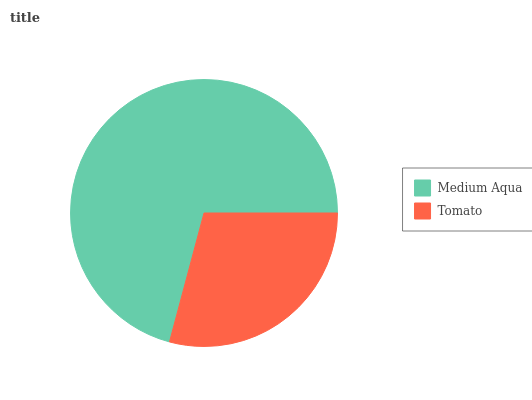Is Tomato the minimum?
Answer yes or no. Yes. Is Medium Aqua the maximum?
Answer yes or no. Yes. Is Tomato the maximum?
Answer yes or no. No. Is Medium Aqua greater than Tomato?
Answer yes or no. Yes. Is Tomato less than Medium Aqua?
Answer yes or no. Yes. Is Tomato greater than Medium Aqua?
Answer yes or no. No. Is Medium Aqua less than Tomato?
Answer yes or no. No. Is Medium Aqua the high median?
Answer yes or no. Yes. Is Tomato the low median?
Answer yes or no. Yes. Is Tomato the high median?
Answer yes or no. No. Is Medium Aqua the low median?
Answer yes or no. No. 